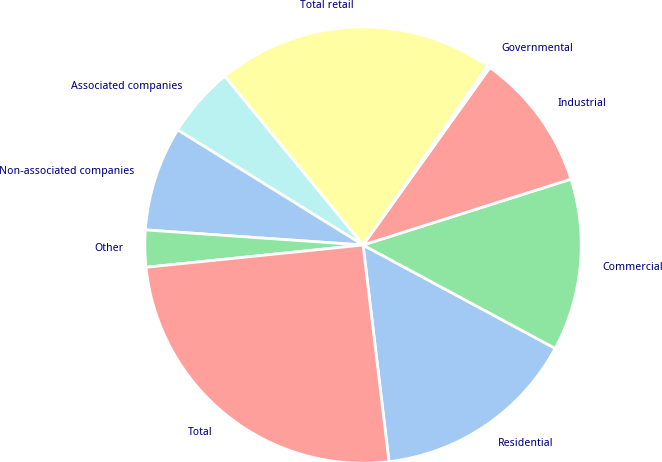<chart> <loc_0><loc_0><loc_500><loc_500><pie_chart><fcel>Residential<fcel>Commercial<fcel>Industrial<fcel>Governmental<fcel>Total retail<fcel>Associated companies<fcel>Non-associated companies<fcel>Other<fcel>Total<nl><fcel>15.25%<fcel>12.74%<fcel>10.24%<fcel>0.22%<fcel>20.58%<fcel>5.23%<fcel>7.74%<fcel>2.73%<fcel>25.27%<nl></chart> 